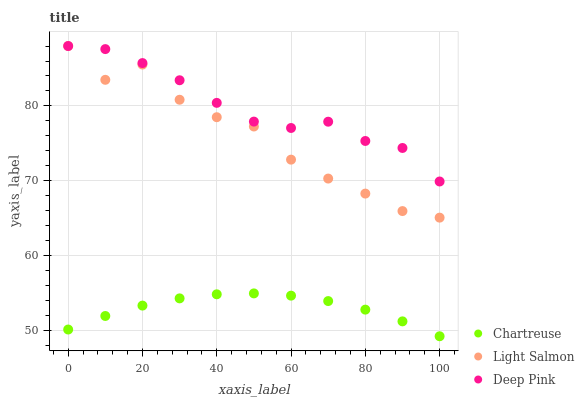Does Chartreuse have the minimum area under the curve?
Answer yes or no. Yes. Does Deep Pink have the maximum area under the curve?
Answer yes or no. Yes. Does Light Salmon have the minimum area under the curve?
Answer yes or no. No. Does Light Salmon have the maximum area under the curve?
Answer yes or no. No. Is Chartreuse the smoothest?
Answer yes or no. Yes. Is Light Salmon the roughest?
Answer yes or no. Yes. Is Deep Pink the smoothest?
Answer yes or no. No. Is Deep Pink the roughest?
Answer yes or no. No. Does Chartreuse have the lowest value?
Answer yes or no. Yes. Does Light Salmon have the lowest value?
Answer yes or no. No. Does Light Salmon have the highest value?
Answer yes or no. Yes. Is Chartreuse less than Light Salmon?
Answer yes or no. Yes. Is Deep Pink greater than Chartreuse?
Answer yes or no. Yes. Does Light Salmon intersect Deep Pink?
Answer yes or no. Yes. Is Light Salmon less than Deep Pink?
Answer yes or no. No. Is Light Salmon greater than Deep Pink?
Answer yes or no. No. Does Chartreuse intersect Light Salmon?
Answer yes or no. No. 